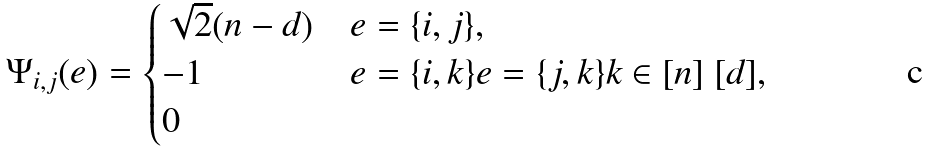Convert formula to latex. <formula><loc_0><loc_0><loc_500><loc_500>\Psi _ { i , j } ( e ) = \begin{cases} \sqrt { 2 } ( n - d ) & e = \{ i , j \} , \\ - 1 & e = \{ i , k \} e = \{ j , k \} k \in [ n ] \ [ d ] , \\ 0 & \end{cases}</formula> 